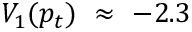<formula> <loc_0><loc_0><loc_500><loc_500>V _ { 1 } ( p _ { t } ) \approx - 2 . 3</formula> 